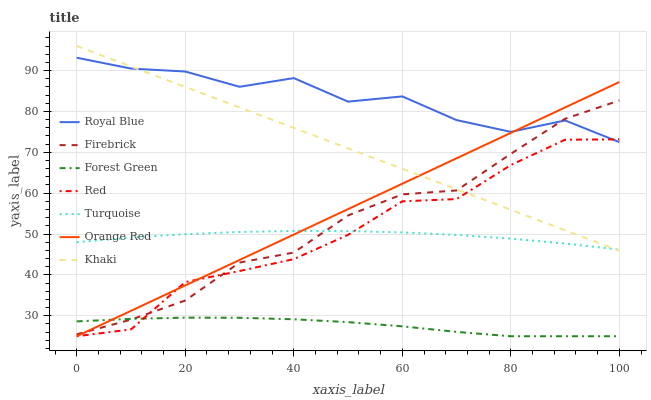Does Forest Green have the minimum area under the curve?
Answer yes or no. Yes. Does Royal Blue have the maximum area under the curve?
Answer yes or no. Yes. Does Khaki have the minimum area under the curve?
Answer yes or no. No. Does Khaki have the maximum area under the curve?
Answer yes or no. No. Is Orange Red the smoothest?
Answer yes or no. Yes. Is Royal Blue the roughest?
Answer yes or no. Yes. Is Khaki the smoothest?
Answer yes or no. No. Is Khaki the roughest?
Answer yes or no. No. Does Forest Green have the lowest value?
Answer yes or no. Yes. Does Khaki have the lowest value?
Answer yes or no. No. Does Khaki have the highest value?
Answer yes or no. Yes. Does Firebrick have the highest value?
Answer yes or no. No. Is Forest Green less than Turquoise?
Answer yes or no. Yes. Is Turquoise greater than Forest Green?
Answer yes or no. Yes. Does Red intersect Royal Blue?
Answer yes or no. Yes. Is Red less than Royal Blue?
Answer yes or no. No. Is Red greater than Royal Blue?
Answer yes or no. No. Does Forest Green intersect Turquoise?
Answer yes or no. No. 